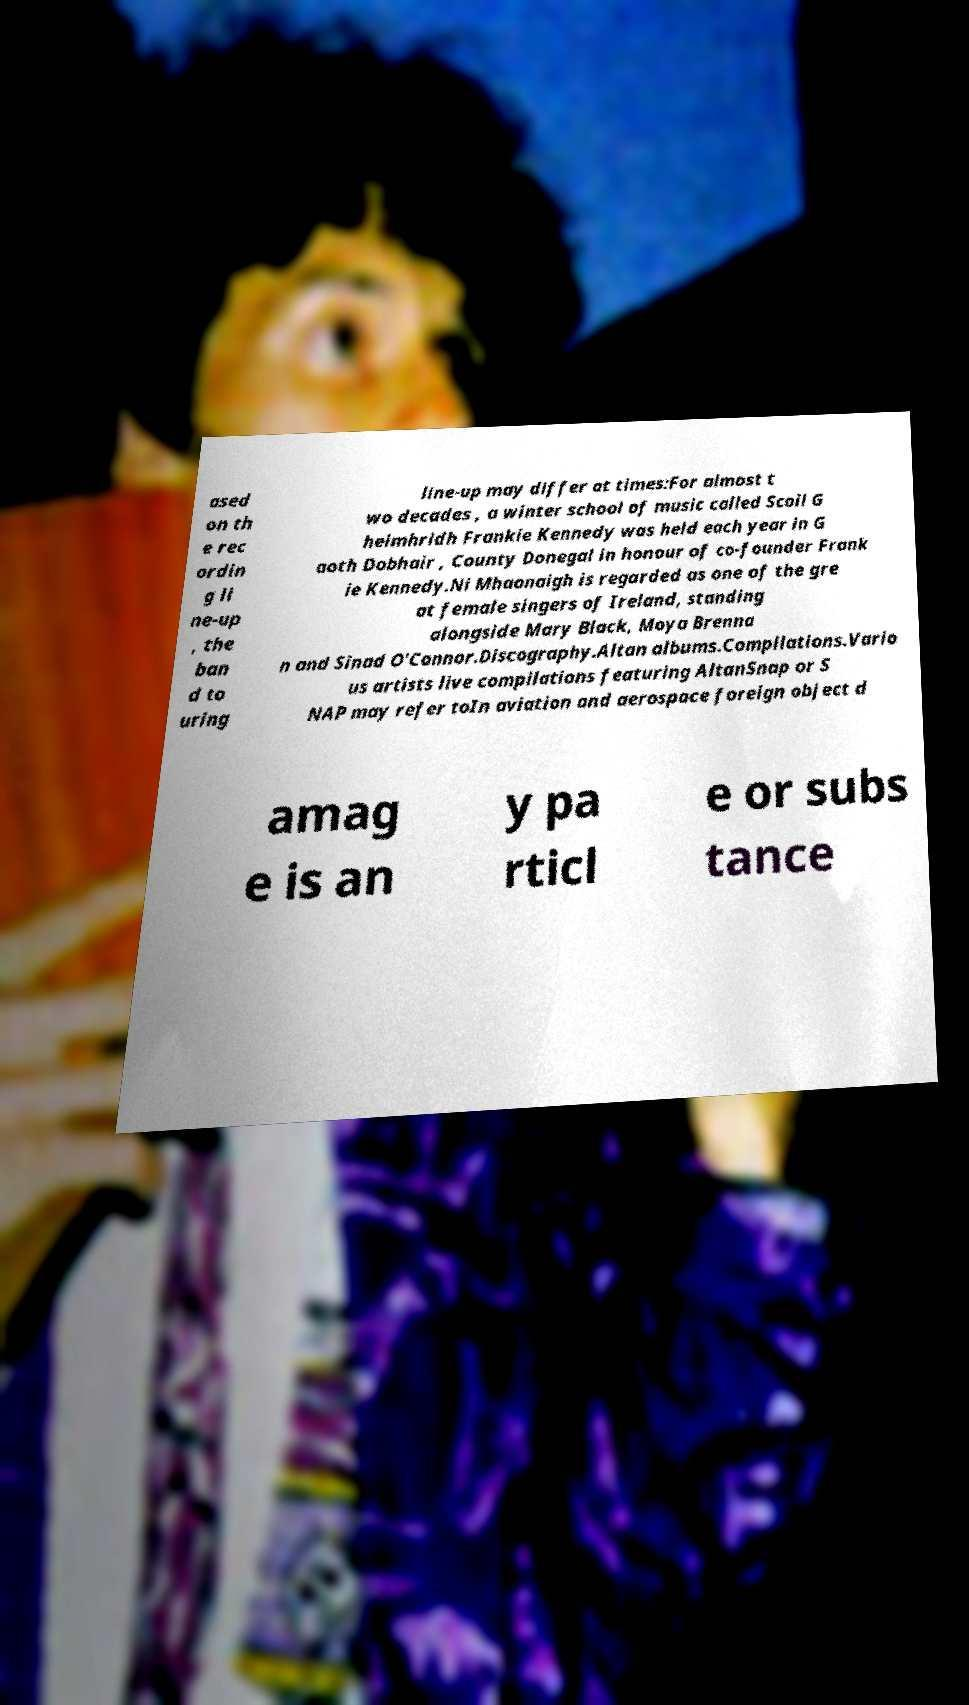There's text embedded in this image that I need extracted. Can you transcribe it verbatim? ased on th e rec ordin g li ne-up , the ban d to uring line-up may differ at times:For almost t wo decades , a winter school of music called Scoil G heimhridh Frankie Kennedy was held each year in G aoth Dobhair , County Donegal in honour of co-founder Frank ie Kennedy.Ni Mhaonaigh is regarded as one of the gre at female singers of Ireland, standing alongside Mary Black, Moya Brenna n and Sinad O'Connor.Discography.Altan albums.Compilations.Vario us artists live compilations featuring AltanSnap or S NAP may refer toIn aviation and aerospace foreign object d amag e is an y pa rticl e or subs tance 